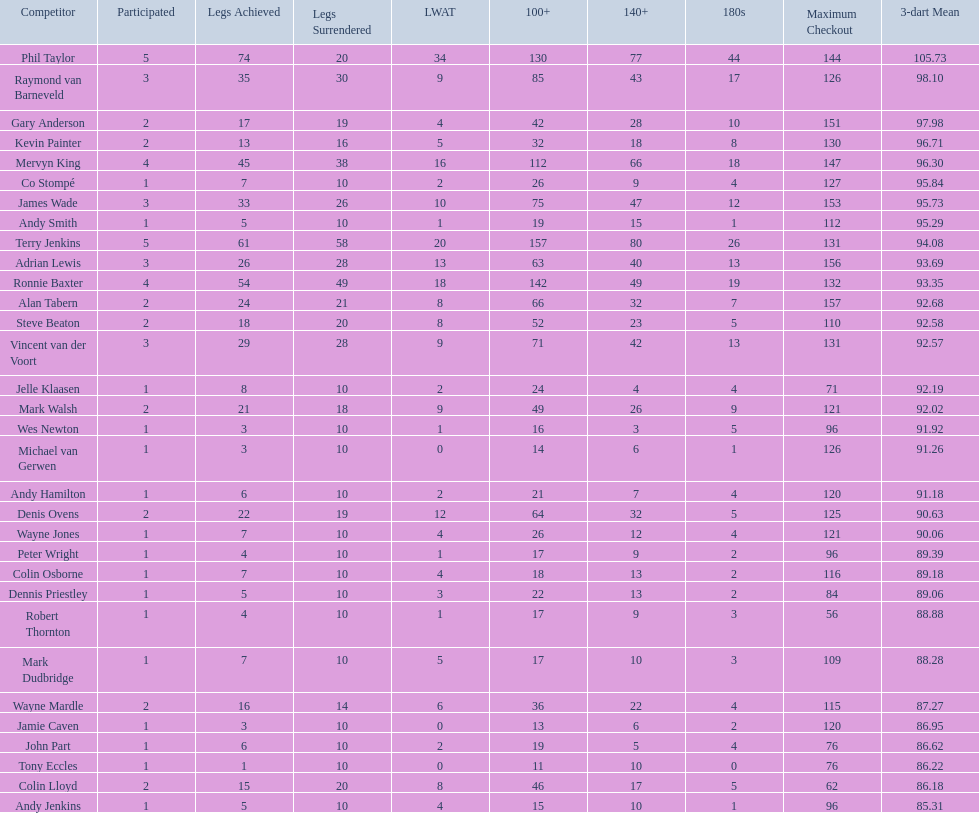What were the total number of legs won by ronnie baxter? 54. 